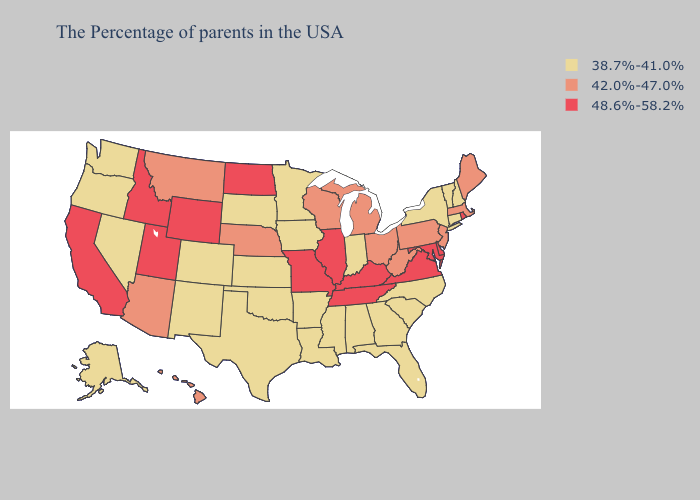What is the highest value in states that border New Jersey?
Concise answer only. 48.6%-58.2%. Does Georgia have the highest value in the USA?
Answer briefly. No. What is the value of Delaware?
Be succinct. 48.6%-58.2%. Does the first symbol in the legend represent the smallest category?
Write a very short answer. Yes. What is the value of North Dakota?
Short answer required. 48.6%-58.2%. What is the value of Utah?
Quick response, please. 48.6%-58.2%. What is the value of Michigan?
Write a very short answer. 42.0%-47.0%. Does the first symbol in the legend represent the smallest category?
Quick response, please. Yes. Does Montana have the highest value in the USA?
Concise answer only. No. Name the states that have a value in the range 48.6%-58.2%?
Give a very brief answer. Rhode Island, Delaware, Maryland, Virginia, Kentucky, Tennessee, Illinois, Missouri, North Dakota, Wyoming, Utah, Idaho, California. Does Hawaii have the lowest value in the West?
Give a very brief answer. No. Name the states that have a value in the range 48.6%-58.2%?
Answer briefly. Rhode Island, Delaware, Maryland, Virginia, Kentucky, Tennessee, Illinois, Missouri, North Dakota, Wyoming, Utah, Idaho, California. What is the value of Missouri?
Answer briefly. 48.6%-58.2%. How many symbols are there in the legend?
Keep it brief. 3. Name the states that have a value in the range 38.7%-41.0%?
Quick response, please. New Hampshire, Vermont, Connecticut, New York, North Carolina, South Carolina, Florida, Georgia, Indiana, Alabama, Mississippi, Louisiana, Arkansas, Minnesota, Iowa, Kansas, Oklahoma, Texas, South Dakota, Colorado, New Mexico, Nevada, Washington, Oregon, Alaska. 